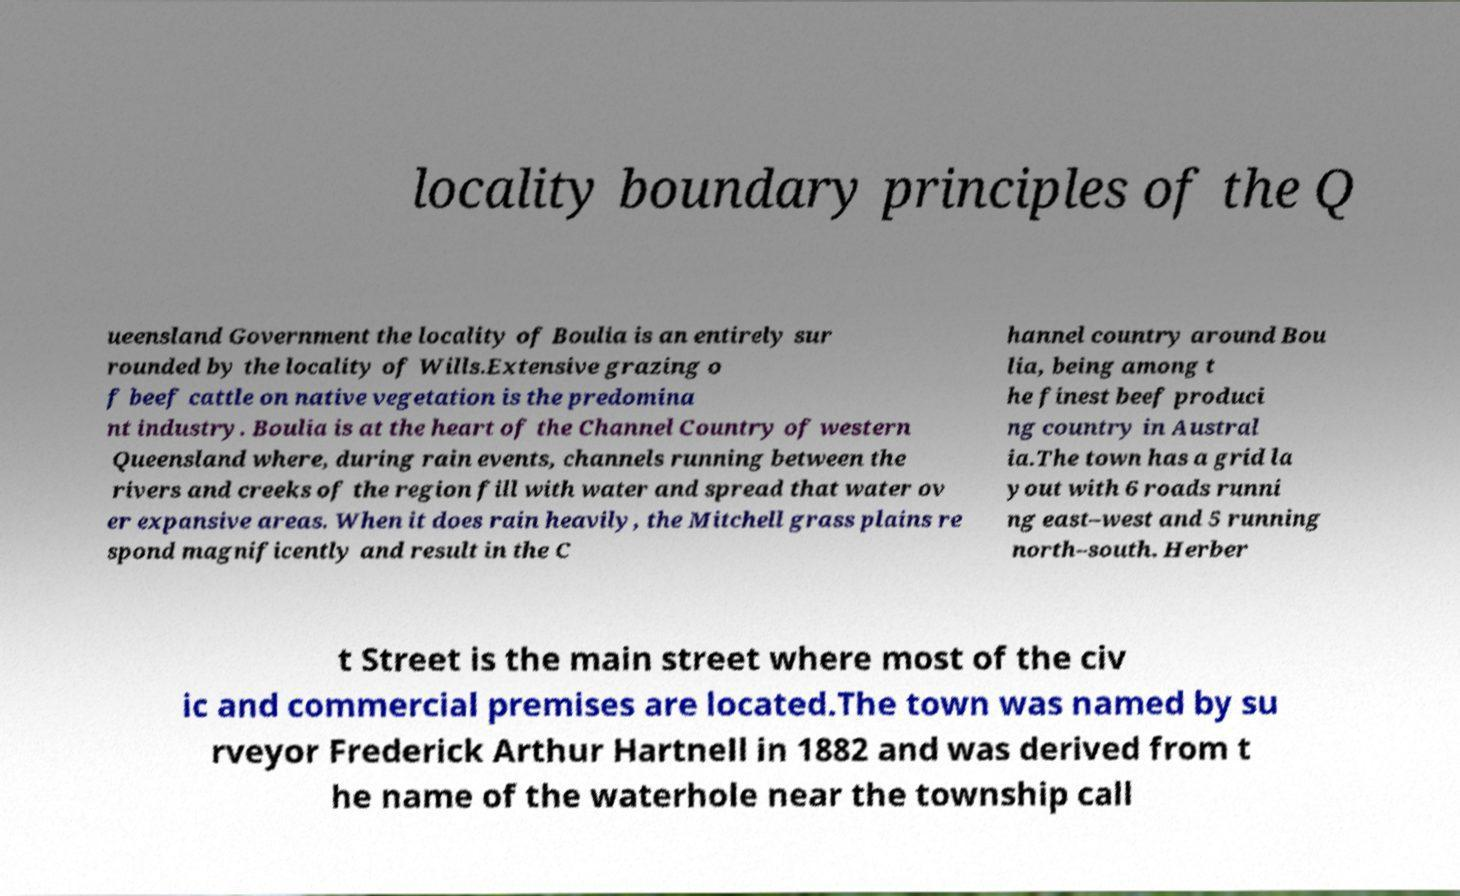What messages or text are displayed in this image? I need them in a readable, typed format. locality boundary principles of the Q ueensland Government the locality of Boulia is an entirely sur rounded by the locality of Wills.Extensive grazing o f beef cattle on native vegetation is the predomina nt industry. Boulia is at the heart of the Channel Country of western Queensland where, during rain events, channels running between the rivers and creeks of the region fill with water and spread that water ov er expansive areas. When it does rain heavily, the Mitchell grass plains re spond magnificently and result in the C hannel country around Bou lia, being among t he finest beef produci ng country in Austral ia.The town has a grid la yout with 6 roads runni ng east–west and 5 running north–south. Herber t Street is the main street where most of the civ ic and commercial premises are located.The town was named by su rveyor Frederick Arthur Hartnell in 1882 and was derived from t he name of the waterhole near the township call 